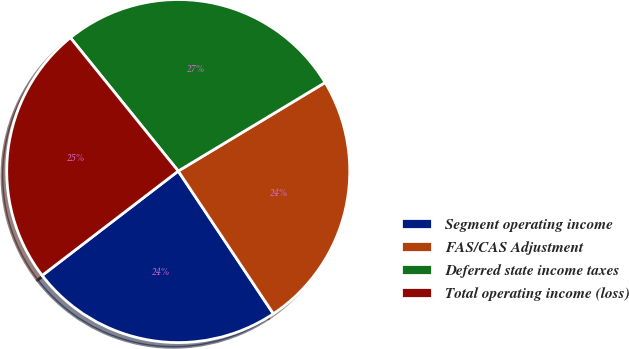Convert chart to OTSL. <chart><loc_0><loc_0><loc_500><loc_500><pie_chart><fcel>Segment operating income<fcel>FAS/CAS Adjustment<fcel>Deferred state income taxes<fcel>Total operating income (loss)<nl><fcel>23.94%<fcel>24.27%<fcel>27.19%<fcel>24.59%<nl></chart> 